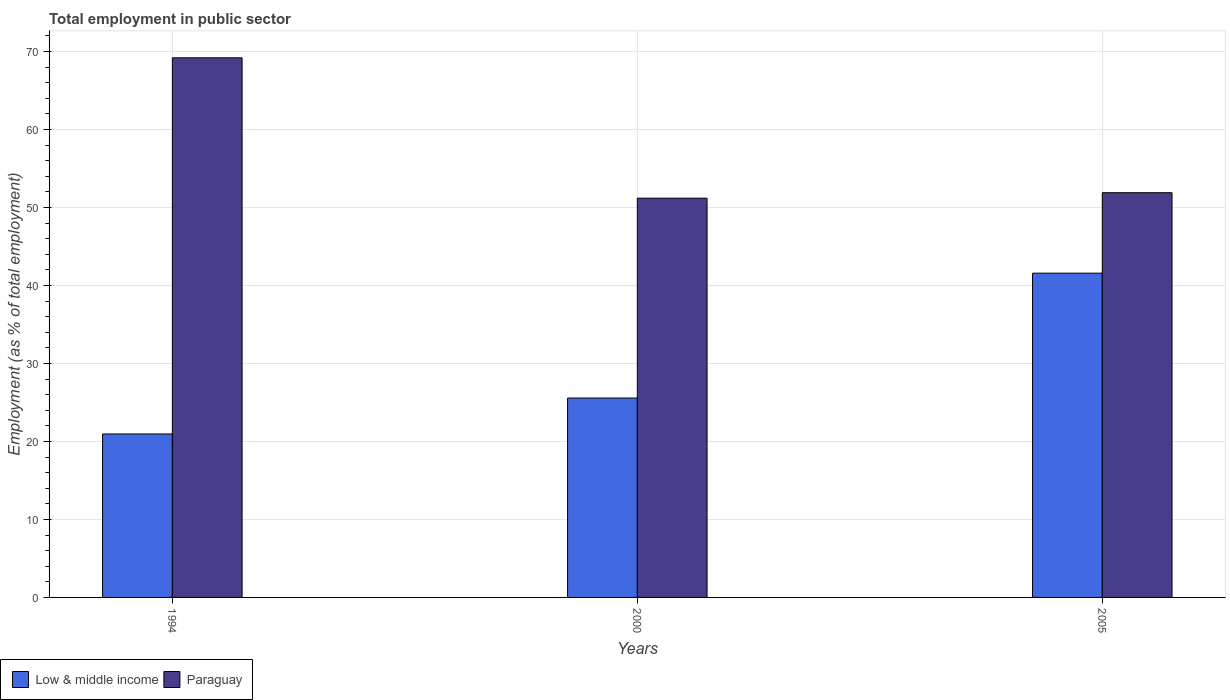How many groups of bars are there?
Provide a short and direct response. 3. Are the number of bars on each tick of the X-axis equal?
Offer a terse response. Yes. How many bars are there on the 1st tick from the left?
Ensure brevity in your answer.  2. How many bars are there on the 2nd tick from the right?
Offer a very short reply. 2. What is the label of the 3rd group of bars from the left?
Ensure brevity in your answer.  2005. What is the employment in public sector in Low & middle income in 2000?
Provide a succinct answer. 25.57. Across all years, what is the maximum employment in public sector in Low & middle income?
Offer a very short reply. 41.58. Across all years, what is the minimum employment in public sector in Paraguay?
Your answer should be very brief. 51.2. In which year was the employment in public sector in Low & middle income maximum?
Make the answer very short. 2005. What is the total employment in public sector in Paraguay in the graph?
Ensure brevity in your answer.  172.3. What is the difference between the employment in public sector in Paraguay in 1994 and that in 2005?
Your answer should be compact. 17.3. What is the difference between the employment in public sector in Paraguay in 2000 and the employment in public sector in Low & middle income in 1994?
Ensure brevity in your answer.  30.24. What is the average employment in public sector in Paraguay per year?
Offer a terse response. 57.43. In the year 1994, what is the difference between the employment in public sector in Paraguay and employment in public sector in Low & middle income?
Keep it short and to the point. 48.24. In how many years, is the employment in public sector in Paraguay greater than 46 %?
Give a very brief answer. 3. What is the ratio of the employment in public sector in Low & middle income in 1994 to that in 2000?
Ensure brevity in your answer.  0.82. Is the employment in public sector in Low & middle income in 2000 less than that in 2005?
Make the answer very short. Yes. What is the difference between the highest and the second highest employment in public sector in Low & middle income?
Make the answer very short. 16.01. What is the difference between the highest and the lowest employment in public sector in Low & middle income?
Offer a very short reply. 20.62. Is the sum of the employment in public sector in Paraguay in 2000 and 2005 greater than the maximum employment in public sector in Low & middle income across all years?
Ensure brevity in your answer.  Yes. What does the 2nd bar from the left in 1994 represents?
Your answer should be very brief. Paraguay. What does the 2nd bar from the right in 1994 represents?
Offer a terse response. Low & middle income. How many bars are there?
Your answer should be very brief. 6. How many years are there in the graph?
Ensure brevity in your answer.  3. Does the graph contain any zero values?
Keep it short and to the point. No. Does the graph contain grids?
Make the answer very short. Yes. Where does the legend appear in the graph?
Give a very brief answer. Bottom left. What is the title of the graph?
Ensure brevity in your answer.  Total employment in public sector. What is the label or title of the X-axis?
Your response must be concise. Years. What is the label or title of the Y-axis?
Provide a succinct answer. Employment (as % of total employment). What is the Employment (as % of total employment) in Low & middle income in 1994?
Ensure brevity in your answer.  20.96. What is the Employment (as % of total employment) of Paraguay in 1994?
Give a very brief answer. 69.2. What is the Employment (as % of total employment) of Low & middle income in 2000?
Ensure brevity in your answer.  25.57. What is the Employment (as % of total employment) of Paraguay in 2000?
Give a very brief answer. 51.2. What is the Employment (as % of total employment) in Low & middle income in 2005?
Make the answer very short. 41.58. What is the Employment (as % of total employment) of Paraguay in 2005?
Ensure brevity in your answer.  51.9. Across all years, what is the maximum Employment (as % of total employment) in Low & middle income?
Offer a very short reply. 41.58. Across all years, what is the maximum Employment (as % of total employment) in Paraguay?
Provide a short and direct response. 69.2. Across all years, what is the minimum Employment (as % of total employment) of Low & middle income?
Your answer should be very brief. 20.96. Across all years, what is the minimum Employment (as % of total employment) in Paraguay?
Ensure brevity in your answer.  51.2. What is the total Employment (as % of total employment) of Low & middle income in the graph?
Your response must be concise. 88.11. What is the total Employment (as % of total employment) in Paraguay in the graph?
Offer a very short reply. 172.3. What is the difference between the Employment (as % of total employment) in Low & middle income in 1994 and that in 2000?
Give a very brief answer. -4.61. What is the difference between the Employment (as % of total employment) of Paraguay in 1994 and that in 2000?
Offer a very short reply. 18. What is the difference between the Employment (as % of total employment) of Low & middle income in 1994 and that in 2005?
Offer a very short reply. -20.62. What is the difference between the Employment (as % of total employment) of Paraguay in 1994 and that in 2005?
Offer a terse response. 17.3. What is the difference between the Employment (as % of total employment) of Low & middle income in 2000 and that in 2005?
Give a very brief answer. -16.01. What is the difference between the Employment (as % of total employment) in Paraguay in 2000 and that in 2005?
Offer a very short reply. -0.7. What is the difference between the Employment (as % of total employment) of Low & middle income in 1994 and the Employment (as % of total employment) of Paraguay in 2000?
Ensure brevity in your answer.  -30.24. What is the difference between the Employment (as % of total employment) of Low & middle income in 1994 and the Employment (as % of total employment) of Paraguay in 2005?
Provide a succinct answer. -30.94. What is the difference between the Employment (as % of total employment) of Low & middle income in 2000 and the Employment (as % of total employment) of Paraguay in 2005?
Offer a very short reply. -26.33. What is the average Employment (as % of total employment) in Low & middle income per year?
Offer a very short reply. 29.37. What is the average Employment (as % of total employment) in Paraguay per year?
Provide a succinct answer. 57.43. In the year 1994, what is the difference between the Employment (as % of total employment) in Low & middle income and Employment (as % of total employment) in Paraguay?
Provide a short and direct response. -48.24. In the year 2000, what is the difference between the Employment (as % of total employment) in Low & middle income and Employment (as % of total employment) in Paraguay?
Offer a terse response. -25.63. In the year 2005, what is the difference between the Employment (as % of total employment) in Low & middle income and Employment (as % of total employment) in Paraguay?
Offer a terse response. -10.32. What is the ratio of the Employment (as % of total employment) in Low & middle income in 1994 to that in 2000?
Make the answer very short. 0.82. What is the ratio of the Employment (as % of total employment) in Paraguay in 1994 to that in 2000?
Provide a succinct answer. 1.35. What is the ratio of the Employment (as % of total employment) in Low & middle income in 1994 to that in 2005?
Make the answer very short. 0.5. What is the ratio of the Employment (as % of total employment) in Low & middle income in 2000 to that in 2005?
Provide a short and direct response. 0.61. What is the ratio of the Employment (as % of total employment) in Paraguay in 2000 to that in 2005?
Offer a terse response. 0.99. What is the difference between the highest and the second highest Employment (as % of total employment) of Low & middle income?
Offer a very short reply. 16.01. What is the difference between the highest and the lowest Employment (as % of total employment) of Low & middle income?
Make the answer very short. 20.62. 